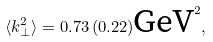<formula> <loc_0><loc_0><loc_500><loc_500>\langle k _ { \bot } ^ { 2 } \rangle = 0 . 7 3 \, ( 0 . 2 2 ) \text {GeV} ^ { 2 } ,</formula> 